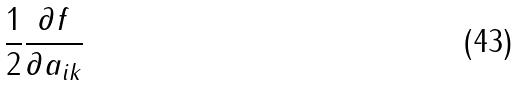Convert formula to latex. <formula><loc_0><loc_0><loc_500><loc_500>\frac { 1 } { 2 } \frac { \partial f } { \partial a _ { i k } }</formula> 